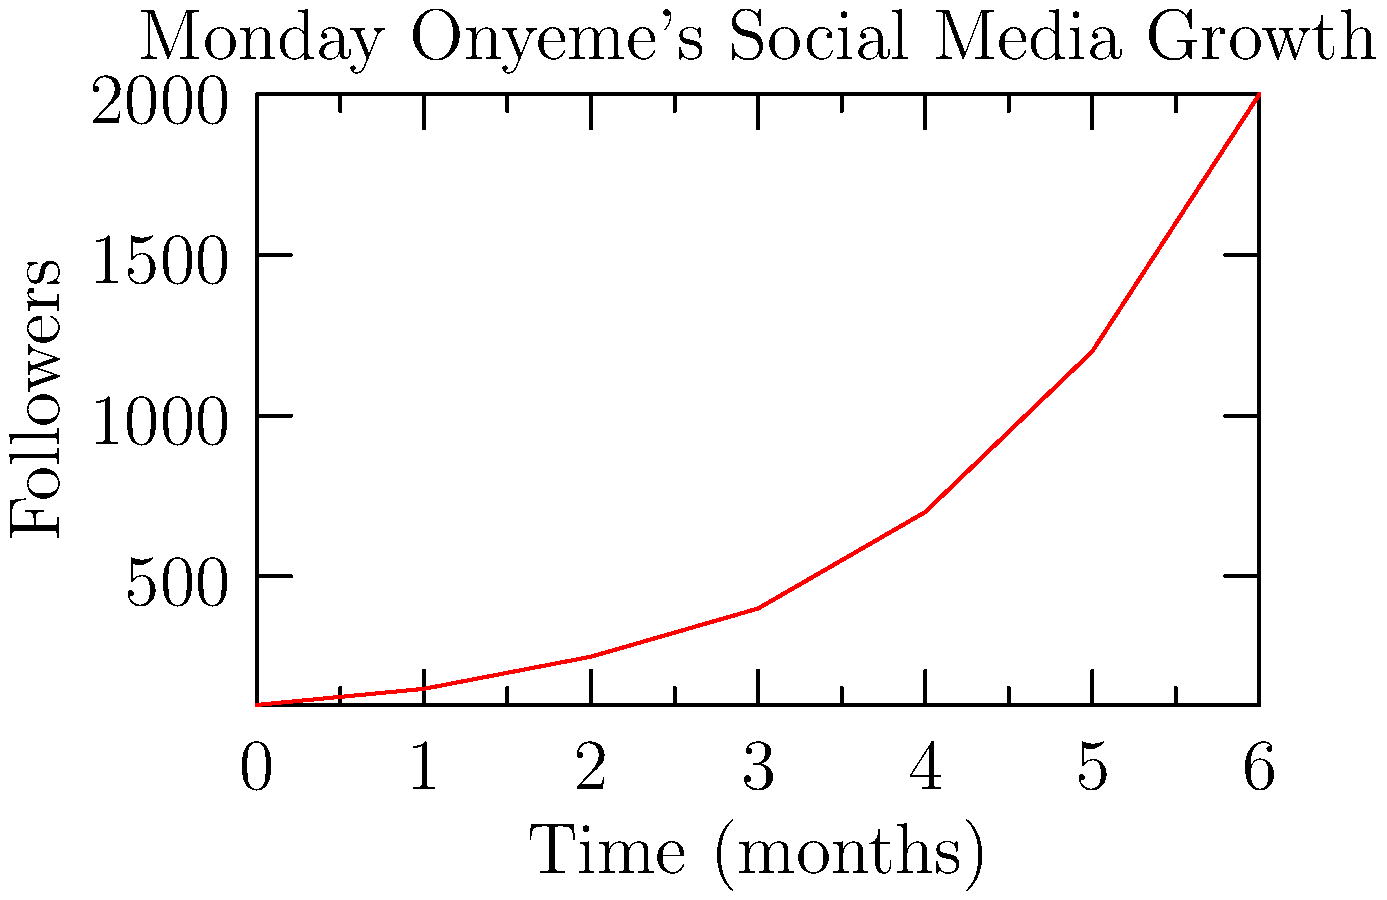Based on the graph showing Monday Onyeme's social media growth over 6 months, what was the average monthly increase in followers between the 3rd and 5th month? To find the average monthly increase in followers between the 3rd and 5th month, we need to:

1. Identify the number of followers at the 3rd month: 400
2. Identify the number of followers at the 5th month: 1200
3. Calculate the total increase: $1200 - 400 = 800$ followers
4. Determine the time period: $5 - 3 = 2$ months
5. Calculate the average monthly increase: $\frac{800}{2} = 400$ followers per month

Therefore, the average monthly increase in followers between the 3rd and 5th month was 400.
Answer: 400 followers/month 